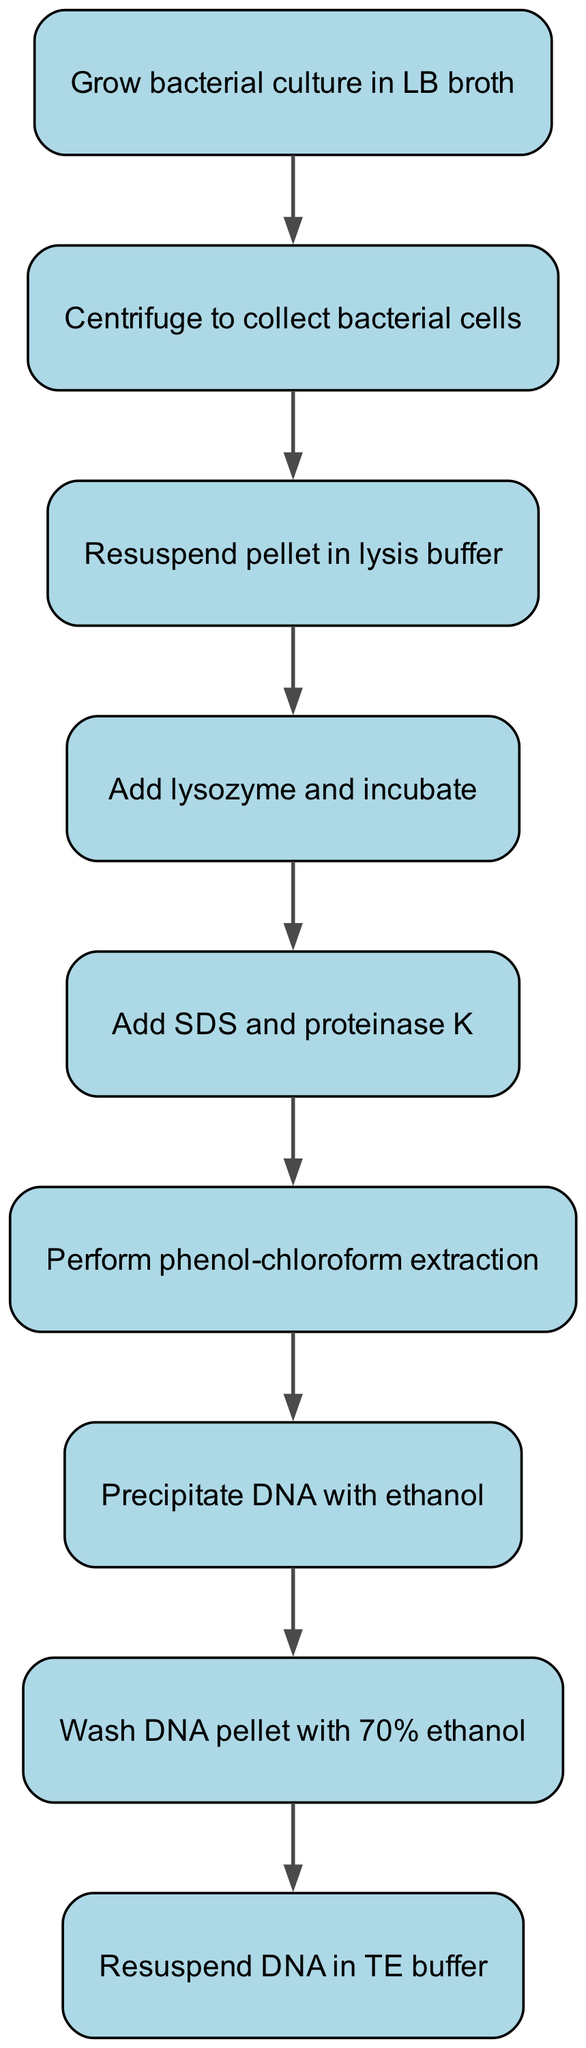What is the first step in the DNA extraction process? The first step is indicated by the first node in the diagram, which states to "Grow bacterial culture in LB broth."
Answer: Grow bacterial culture in LB broth How many steps are there in the procedure? By counting all the nodes in the diagram, there are nine steps in total as each node represents a step in the DNA extraction process.
Answer: Nine What do you add to the lysate after incubating with lysozyme? The diagram shows that after incubating with lysozyme, the next step indicates adding "SDS and proteinase K."
Answer: SDS and proteinase K What process follows after precipitating DNA with ethanol? The diagram clearly states that after precipitating DNA with ethanol, the next step is to "Wash DNA pellet with 70% ethanol."
Answer: Wash DNA pellet with 70% ethanol Which step involves centrifugation? The second node in the diagram details a step which is "Centrifuge to collect bacterial cells," indicating the process of centrifugation.
Answer: Centrifuge to collect bacterial cells What is the connection between the steps 'Add lysozyme and incubate' and 'Add SDS and proteinase K'? The diagram shows a direct connection from the step "Add lysozyme and incubate" to "Add SDS and proteinase K," indicating that these steps are sequential and one directly follows the other in the process.
Answer: They are sequential steps Which step directly precedes the 'Resuspend DNA in TE buffer' step? By tracing the connections backward from the final step, we see that "Wash DNA pellet with 70% ethanol" directly precedes "Resuspend DNA in TE buffer."
Answer: Wash DNA pellet with 70% ethanol What is the final step of the DNA extraction procedure? The last node in the diagram indicates that the final step in the procedure is to "Resuspend DNA in TE buffer."
Answer: Resuspend DNA in TE buffer What reasoning can you derive about the overall flow of the procedure? Observing the connections between all nodes shows that the procedure is linear; each step must be completed in order, leading directly from the initial growth of the bacterial culture to the final resuspension of DNA.
Answer: The procedure is linear 